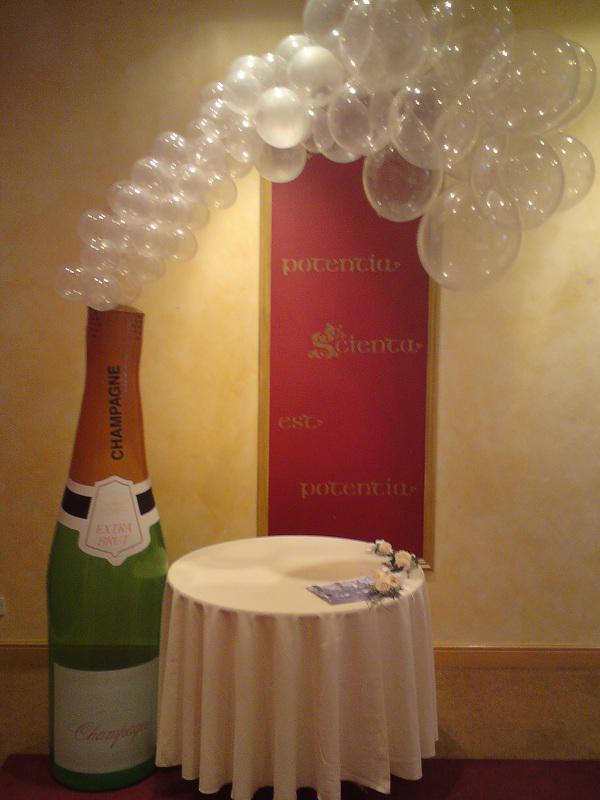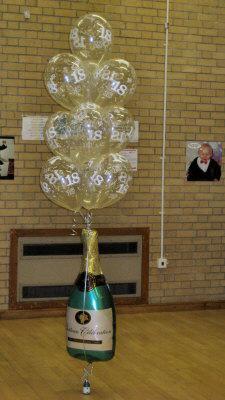The first image is the image on the left, the second image is the image on the right. Examine the images to the left and right. Is the description "A bottle is on the right side of a door." accurate? Answer yes or no. No. 